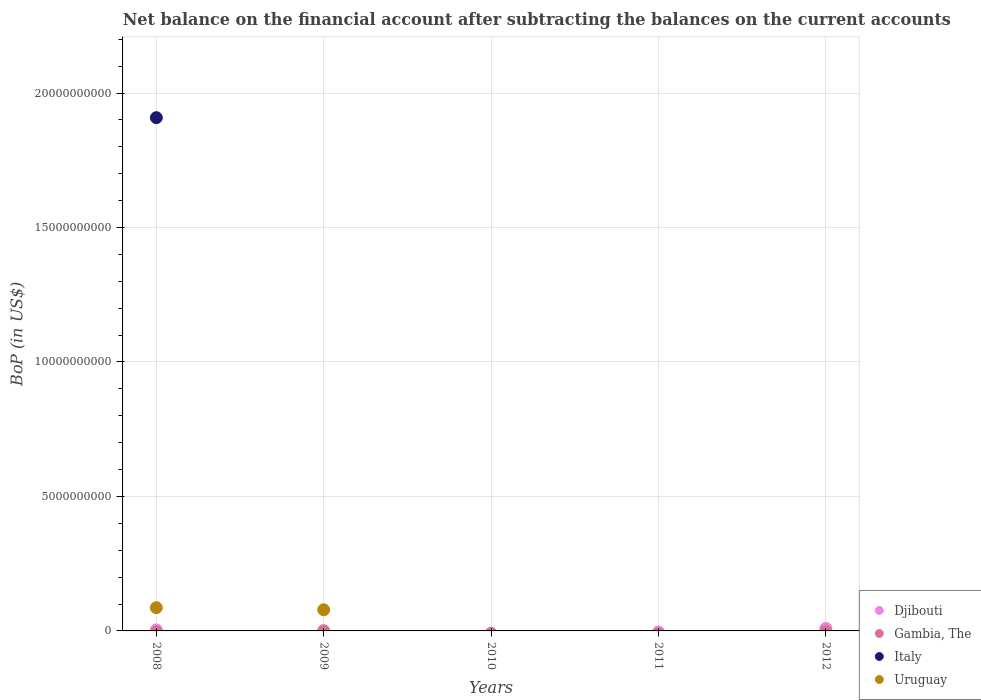How many different coloured dotlines are there?
Offer a terse response. 4. Is the number of dotlines equal to the number of legend labels?
Ensure brevity in your answer.  No. Across all years, what is the maximum Balance of Payments in Djibouti?
Your answer should be very brief. 9.65e+07. Across all years, what is the minimum Balance of Payments in Djibouti?
Offer a very short reply. 0. In which year was the Balance of Payments in Uruguay maximum?
Keep it short and to the point. 2008. What is the total Balance of Payments in Djibouti in the graph?
Give a very brief answer. 1.34e+08. What is the average Balance of Payments in Italy per year?
Offer a very short reply. 3.82e+09. What is the difference between the highest and the lowest Balance of Payments in Gambia, The?
Provide a short and direct response. 7.24e+06. In how many years, is the Balance of Payments in Gambia, The greater than the average Balance of Payments in Gambia, The taken over all years?
Keep it short and to the point. 1. Is it the case that in every year, the sum of the Balance of Payments in Uruguay and Balance of Payments in Djibouti  is greater than the Balance of Payments in Gambia, The?
Your answer should be very brief. No. Does the Balance of Payments in Italy monotonically increase over the years?
Provide a short and direct response. No. How many dotlines are there?
Ensure brevity in your answer.  4. How many years are there in the graph?
Provide a succinct answer. 5. Are the values on the major ticks of Y-axis written in scientific E-notation?
Provide a succinct answer. No. Does the graph contain grids?
Give a very brief answer. Yes. Where does the legend appear in the graph?
Your response must be concise. Bottom right. How many legend labels are there?
Provide a short and direct response. 4. What is the title of the graph?
Provide a short and direct response. Net balance on the financial account after subtracting the balances on the current accounts. What is the label or title of the Y-axis?
Provide a short and direct response. BoP (in US$). What is the BoP (in US$) of Djibouti in 2008?
Provide a succinct answer. 3.79e+07. What is the BoP (in US$) of Gambia, The in 2008?
Your answer should be very brief. 0. What is the BoP (in US$) in Italy in 2008?
Provide a short and direct response. 1.91e+1. What is the BoP (in US$) in Uruguay in 2008?
Your answer should be very brief. 8.64e+08. What is the BoP (in US$) of Djibouti in 2009?
Your answer should be compact. 0. What is the BoP (in US$) in Gambia, The in 2009?
Give a very brief answer. 7.24e+06. What is the BoP (in US$) in Uruguay in 2009?
Ensure brevity in your answer.  7.86e+08. What is the BoP (in US$) of Djibouti in 2010?
Ensure brevity in your answer.  0. What is the BoP (in US$) of Djibouti in 2011?
Offer a terse response. 0. What is the BoP (in US$) of Gambia, The in 2011?
Your answer should be very brief. 0. What is the BoP (in US$) in Djibouti in 2012?
Offer a terse response. 9.65e+07. What is the BoP (in US$) in Italy in 2012?
Ensure brevity in your answer.  0. Across all years, what is the maximum BoP (in US$) in Djibouti?
Make the answer very short. 9.65e+07. Across all years, what is the maximum BoP (in US$) in Gambia, The?
Offer a terse response. 7.24e+06. Across all years, what is the maximum BoP (in US$) of Italy?
Ensure brevity in your answer.  1.91e+1. Across all years, what is the maximum BoP (in US$) of Uruguay?
Provide a succinct answer. 8.64e+08. Across all years, what is the minimum BoP (in US$) of Gambia, The?
Offer a terse response. 0. What is the total BoP (in US$) in Djibouti in the graph?
Offer a very short reply. 1.34e+08. What is the total BoP (in US$) in Gambia, The in the graph?
Keep it short and to the point. 7.24e+06. What is the total BoP (in US$) in Italy in the graph?
Offer a terse response. 1.91e+1. What is the total BoP (in US$) in Uruguay in the graph?
Ensure brevity in your answer.  1.65e+09. What is the difference between the BoP (in US$) of Uruguay in 2008 and that in 2009?
Make the answer very short. 7.78e+07. What is the difference between the BoP (in US$) of Djibouti in 2008 and that in 2012?
Offer a terse response. -5.86e+07. What is the difference between the BoP (in US$) of Djibouti in 2008 and the BoP (in US$) of Gambia, The in 2009?
Offer a very short reply. 3.07e+07. What is the difference between the BoP (in US$) in Djibouti in 2008 and the BoP (in US$) in Uruguay in 2009?
Keep it short and to the point. -7.48e+08. What is the difference between the BoP (in US$) of Italy in 2008 and the BoP (in US$) of Uruguay in 2009?
Make the answer very short. 1.83e+1. What is the average BoP (in US$) in Djibouti per year?
Offer a very short reply. 2.69e+07. What is the average BoP (in US$) of Gambia, The per year?
Your response must be concise. 1.45e+06. What is the average BoP (in US$) of Italy per year?
Your answer should be compact. 3.82e+09. What is the average BoP (in US$) of Uruguay per year?
Your answer should be very brief. 3.30e+08. In the year 2008, what is the difference between the BoP (in US$) in Djibouti and BoP (in US$) in Italy?
Offer a terse response. -1.90e+1. In the year 2008, what is the difference between the BoP (in US$) in Djibouti and BoP (in US$) in Uruguay?
Give a very brief answer. -8.26e+08. In the year 2008, what is the difference between the BoP (in US$) of Italy and BoP (in US$) of Uruguay?
Offer a terse response. 1.82e+1. In the year 2009, what is the difference between the BoP (in US$) in Gambia, The and BoP (in US$) in Uruguay?
Provide a succinct answer. -7.79e+08. What is the ratio of the BoP (in US$) in Uruguay in 2008 to that in 2009?
Ensure brevity in your answer.  1.1. What is the ratio of the BoP (in US$) of Djibouti in 2008 to that in 2012?
Provide a succinct answer. 0.39. What is the difference between the highest and the lowest BoP (in US$) of Djibouti?
Provide a succinct answer. 9.65e+07. What is the difference between the highest and the lowest BoP (in US$) in Gambia, The?
Offer a terse response. 7.24e+06. What is the difference between the highest and the lowest BoP (in US$) in Italy?
Make the answer very short. 1.91e+1. What is the difference between the highest and the lowest BoP (in US$) in Uruguay?
Give a very brief answer. 8.64e+08. 